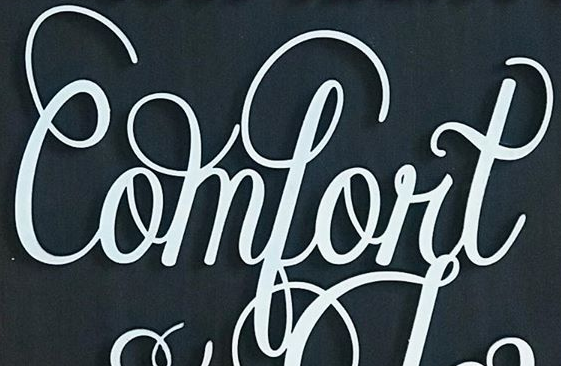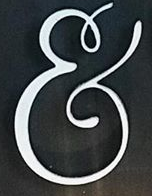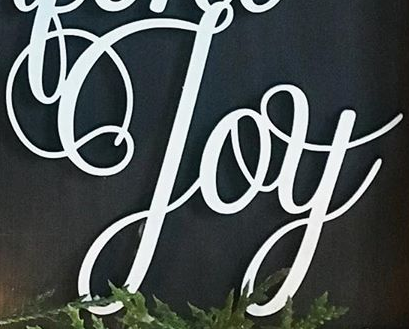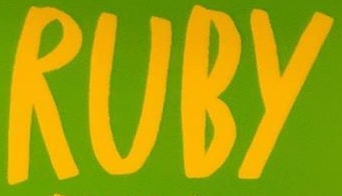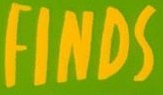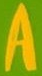What words are shown in these images in order, separated by a semicolon? Comfort; &; Joy; RUBY; FINDS; A 